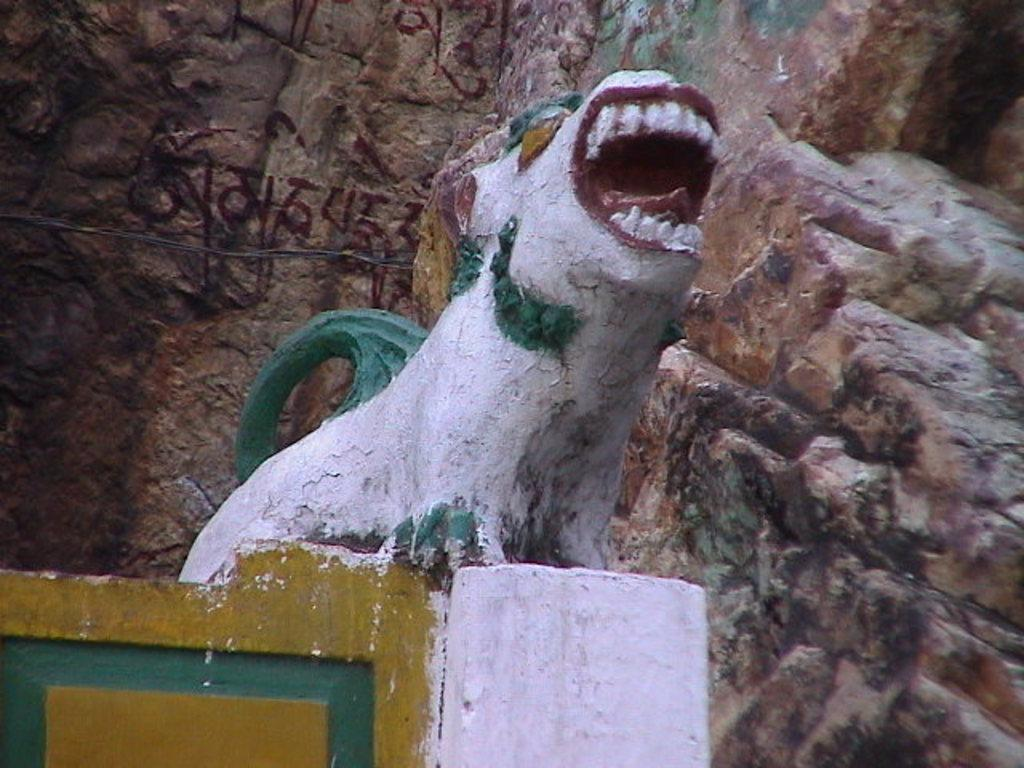What is the main subject in the image? There is a statue in the image. What is located behind the statue? There is a stone wall behind the statue. What type of celery can be seen growing on the stone wall in the image? There is no celery present in the image; it features a statue and a stone wall. 